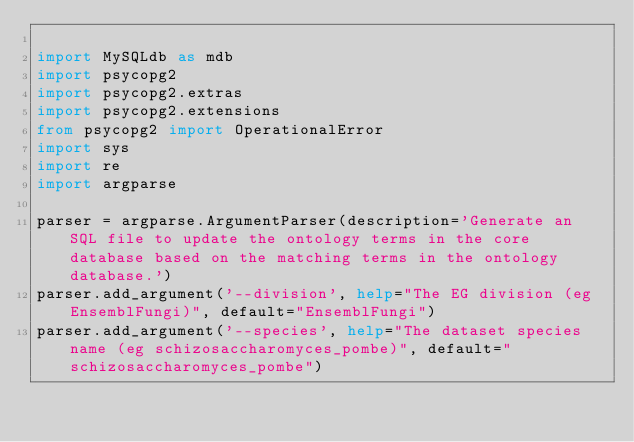<code> <loc_0><loc_0><loc_500><loc_500><_Python_>
import MySQLdb as mdb
import psycopg2
import psycopg2.extras
import psycopg2.extensions
from psycopg2 import OperationalError
import sys
import re
import argparse

parser = argparse.ArgumentParser(description='Generate an SQL file to update the ontology terms in the core database based on the matching terms in the ontology database.')
parser.add_argument('--division', help="The EG division (eg EnsemblFungi)", default="EnsemblFungi")
parser.add_argument('--species', help="The dataset species name (eg schizosaccharomyces_pombe)", default="schizosaccharomyces_pombe")</code> 